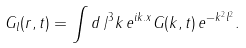Convert formula to latex. <formula><loc_0><loc_0><loc_500><loc_500>G _ { l } ( r , t ) = \int d \, / ^ { 3 } k \, e ^ { i { k } . { x } } G ( k , t ) \, e ^ { - k ^ { 2 } l ^ { 2 } } .</formula> 